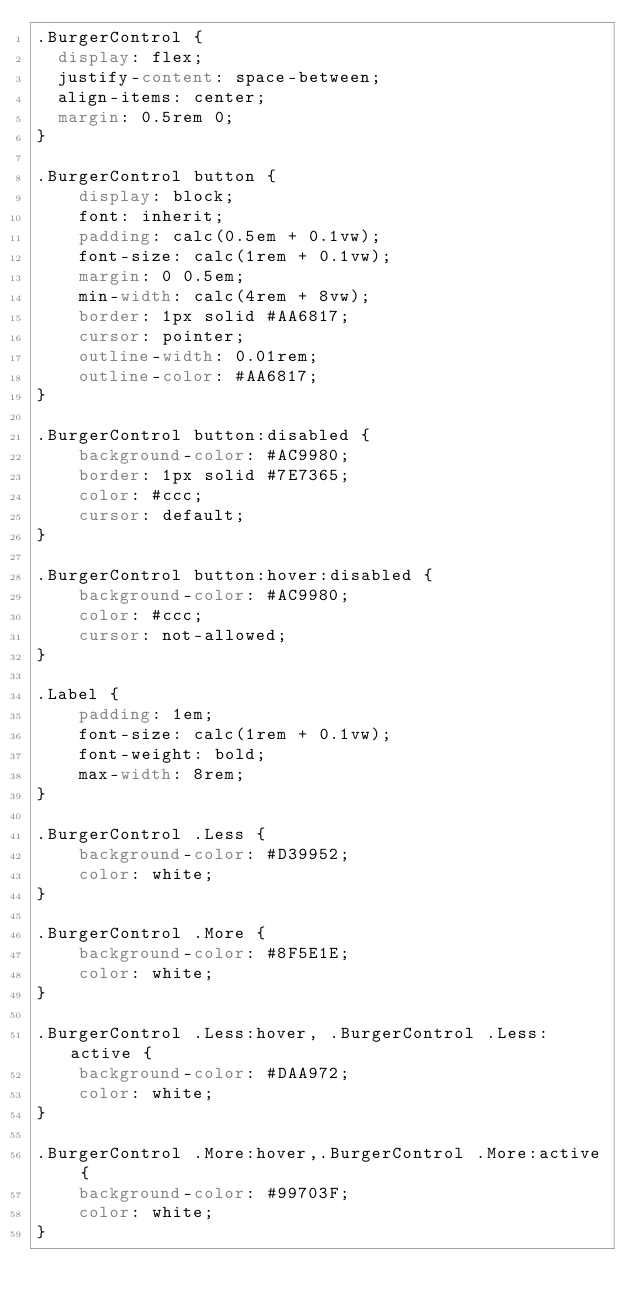Convert code to text. <code><loc_0><loc_0><loc_500><loc_500><_CSS_>.BurgerControl {
	display: flex;
	justify-content: space-between;
	align-items: center;
	margin: 0.5rem 0;
}

.BurgerControl button {
    display: block;
    font: inherit;
    padding: calc(0.5em + 0.1vw);
    font-size: calc(1rem + 0.1vw);
    margin: 0 0.5em;
    min-width: calc(4rem + 8vw);
    border: 1px solid #AA6817;
    cursor: pointer;
    outline-width: 0.01rem;
    outline-color: #AA6817;
}

.BurgerControl button:disabled {
    background-color: #AC9980;
    border: 1px solid #7E7365;
    color: #ccc;
    cursor: default;
}

.BurgerControl button:hover:disabled {
    background-color: #AC9980;
    color: #ccc;
    cursor: not-allowed;
}

.Label {
    padding: 1em;
    font-size: calc(1rem + 0.1vw);
    font-weight: bold;
    max-width: 8rem;
}

.BurgerControl .Less {  
    background-color: #D39952;
    color: white;
}

.BurgerControl .More {
    background-color: #8F5E1E;
    color: white;
}

.BurgerControl .Less:hover, .BurgerControl .Less:active {  
    background-color: #DAA972;
    color: white;
}

.BurgerControl .More:hover,.BurgerControl .More:active {
    background-color: #99703F;
    color: white;
}</code> 